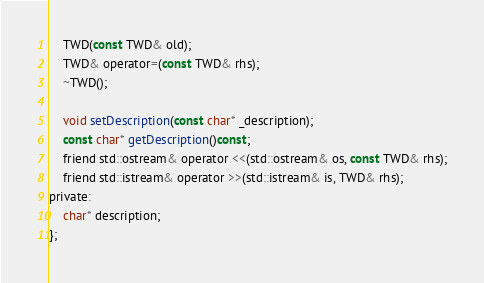Convert code to text. <code><loc_0><loc_0><loc_500><loc_500><_C_>	TWD(const TWD& old);
	TWD& operator=(const TWD& rhs);
	~TWD();

	void setDescription(const char* _description);
	const char* getDescription()const;
	friend std::ostream& operator <<(std::ostream& os, const TWD& rhs);
	friend std::istream& operator >>(std::istream& is, TWD& rhs);
private:
	char* description;
};</code> 